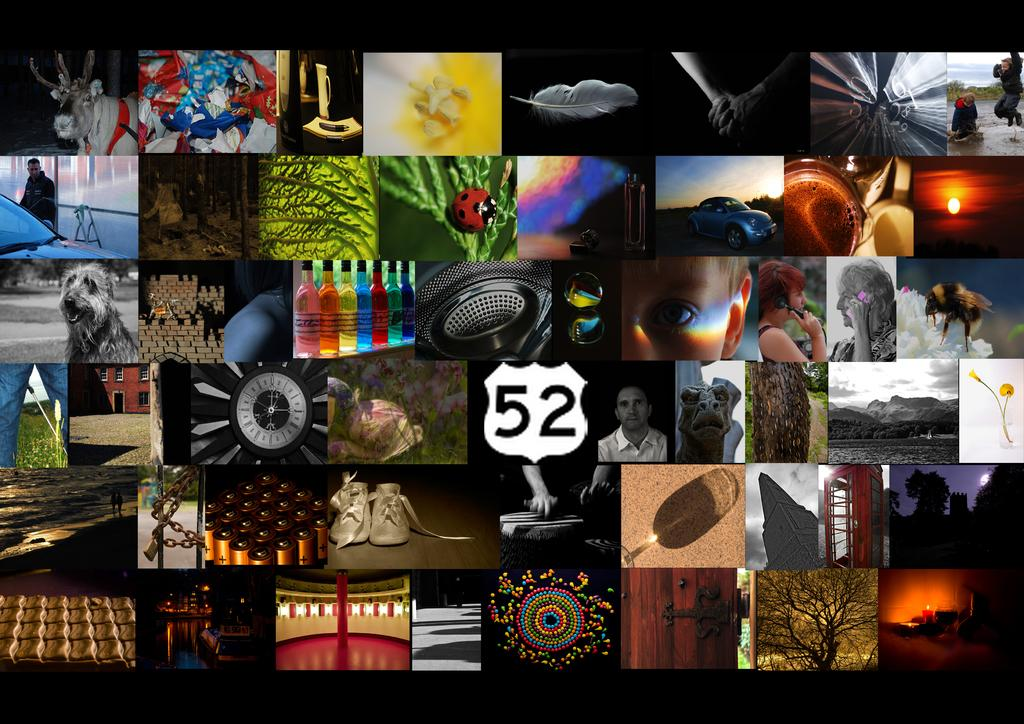<image>
Create a compact narrative representing the image presented. a large photograph with tons of different pictures. 